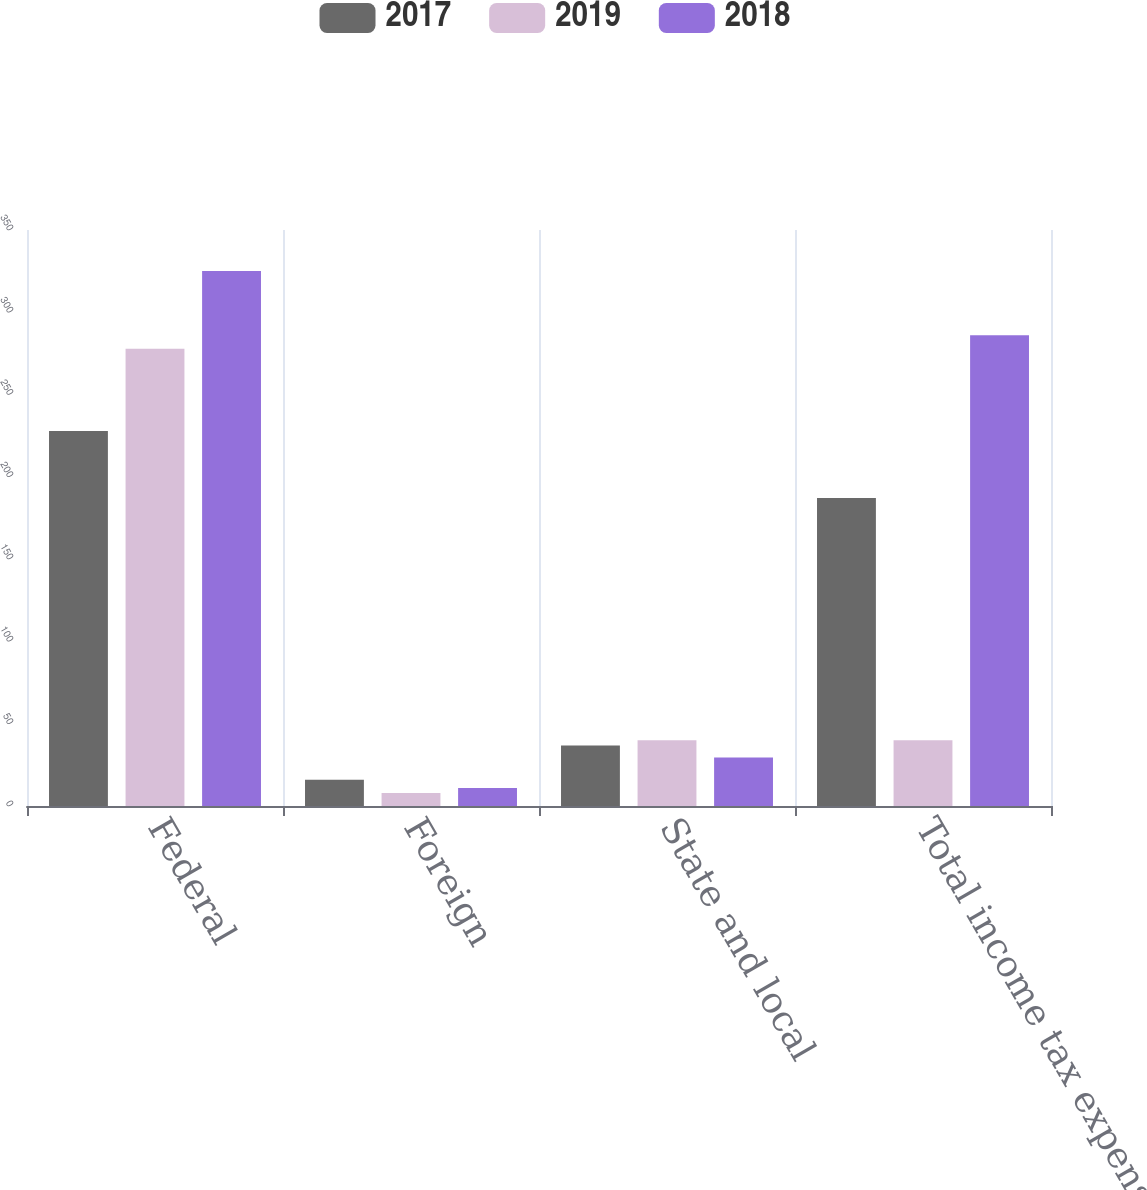Convert chart. <chart><loc_0><loc_0><loc_500><loc_500><stacked_bar_chart><ecel><fcel>Federal<fcel>Foreign<fcel>State and local<fcel>Total income tax expense<nl><fcel>2017<fcel>227.9<fcel>16<fcel>36.8<fcel>187.2<nl><fcel>2019<fcel>277.9<fcel>7.9<fcel>40<fcel>40<nl><fcel>2018<fcel>325.1<fcel>11<fcel>29.4<fcel>286.1<nl></chart> 